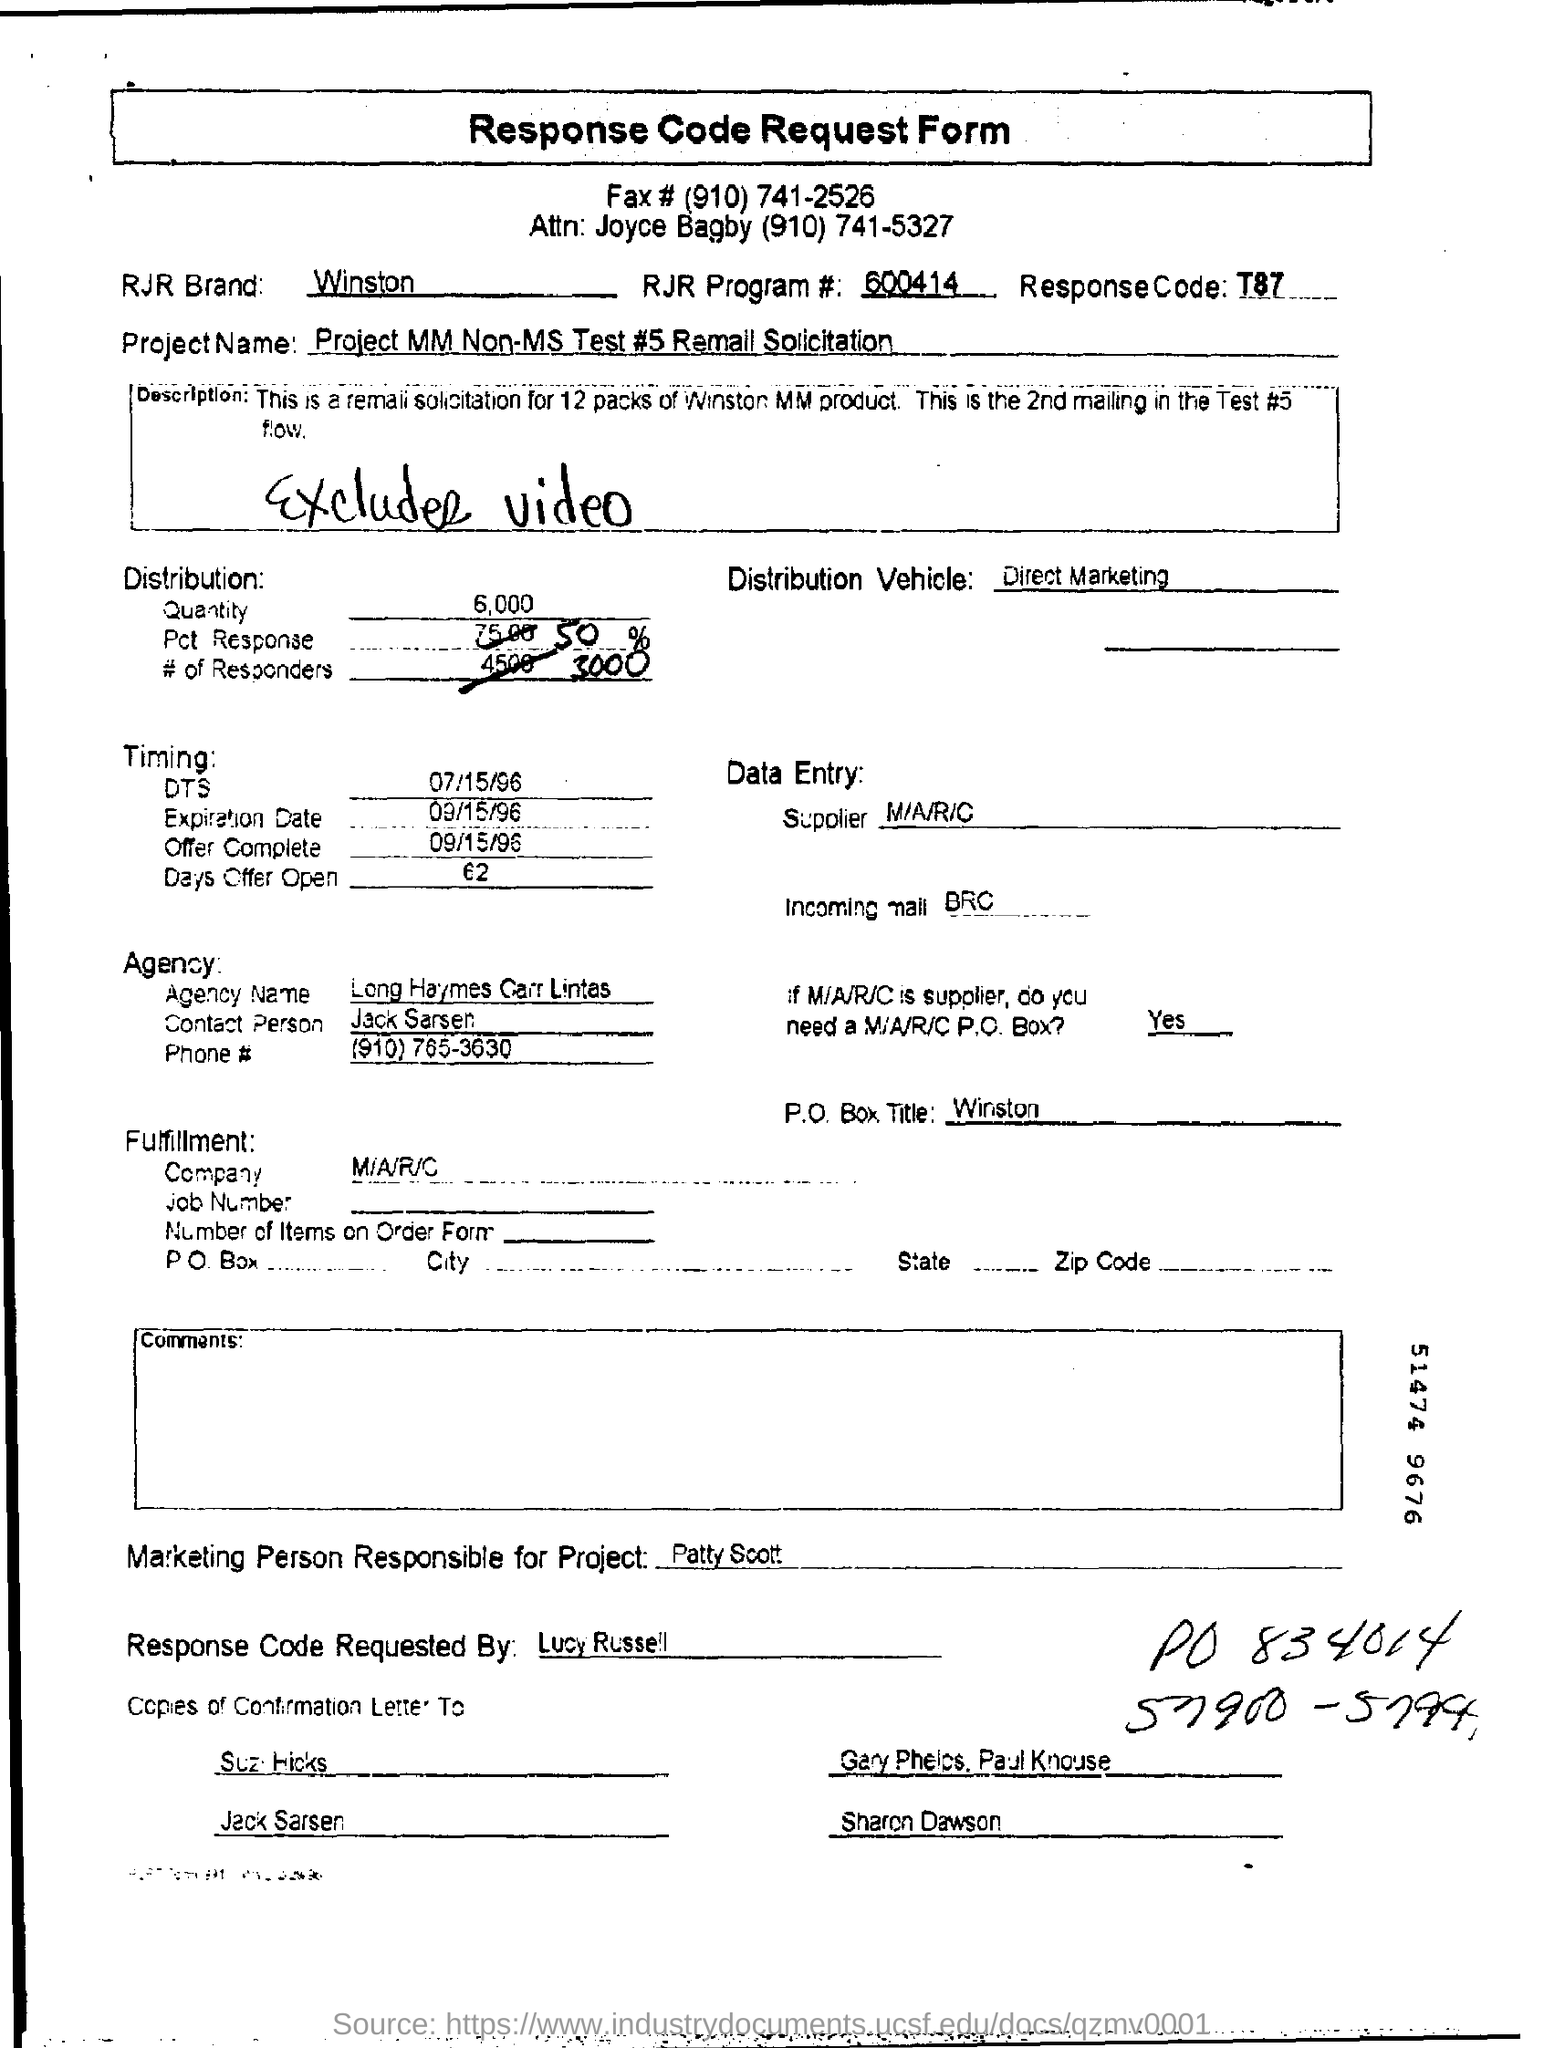What is T87?
Keep it short and to the point. Response Code. What is the Project Name?
Give a very brief answer. Project mm non-ms test #5 remall solicitation. What is the P.O Box Title?
Offer a terse response. Winston. Who is the Agency contact person?
Keep it short and to the point. Jack sarsen. 